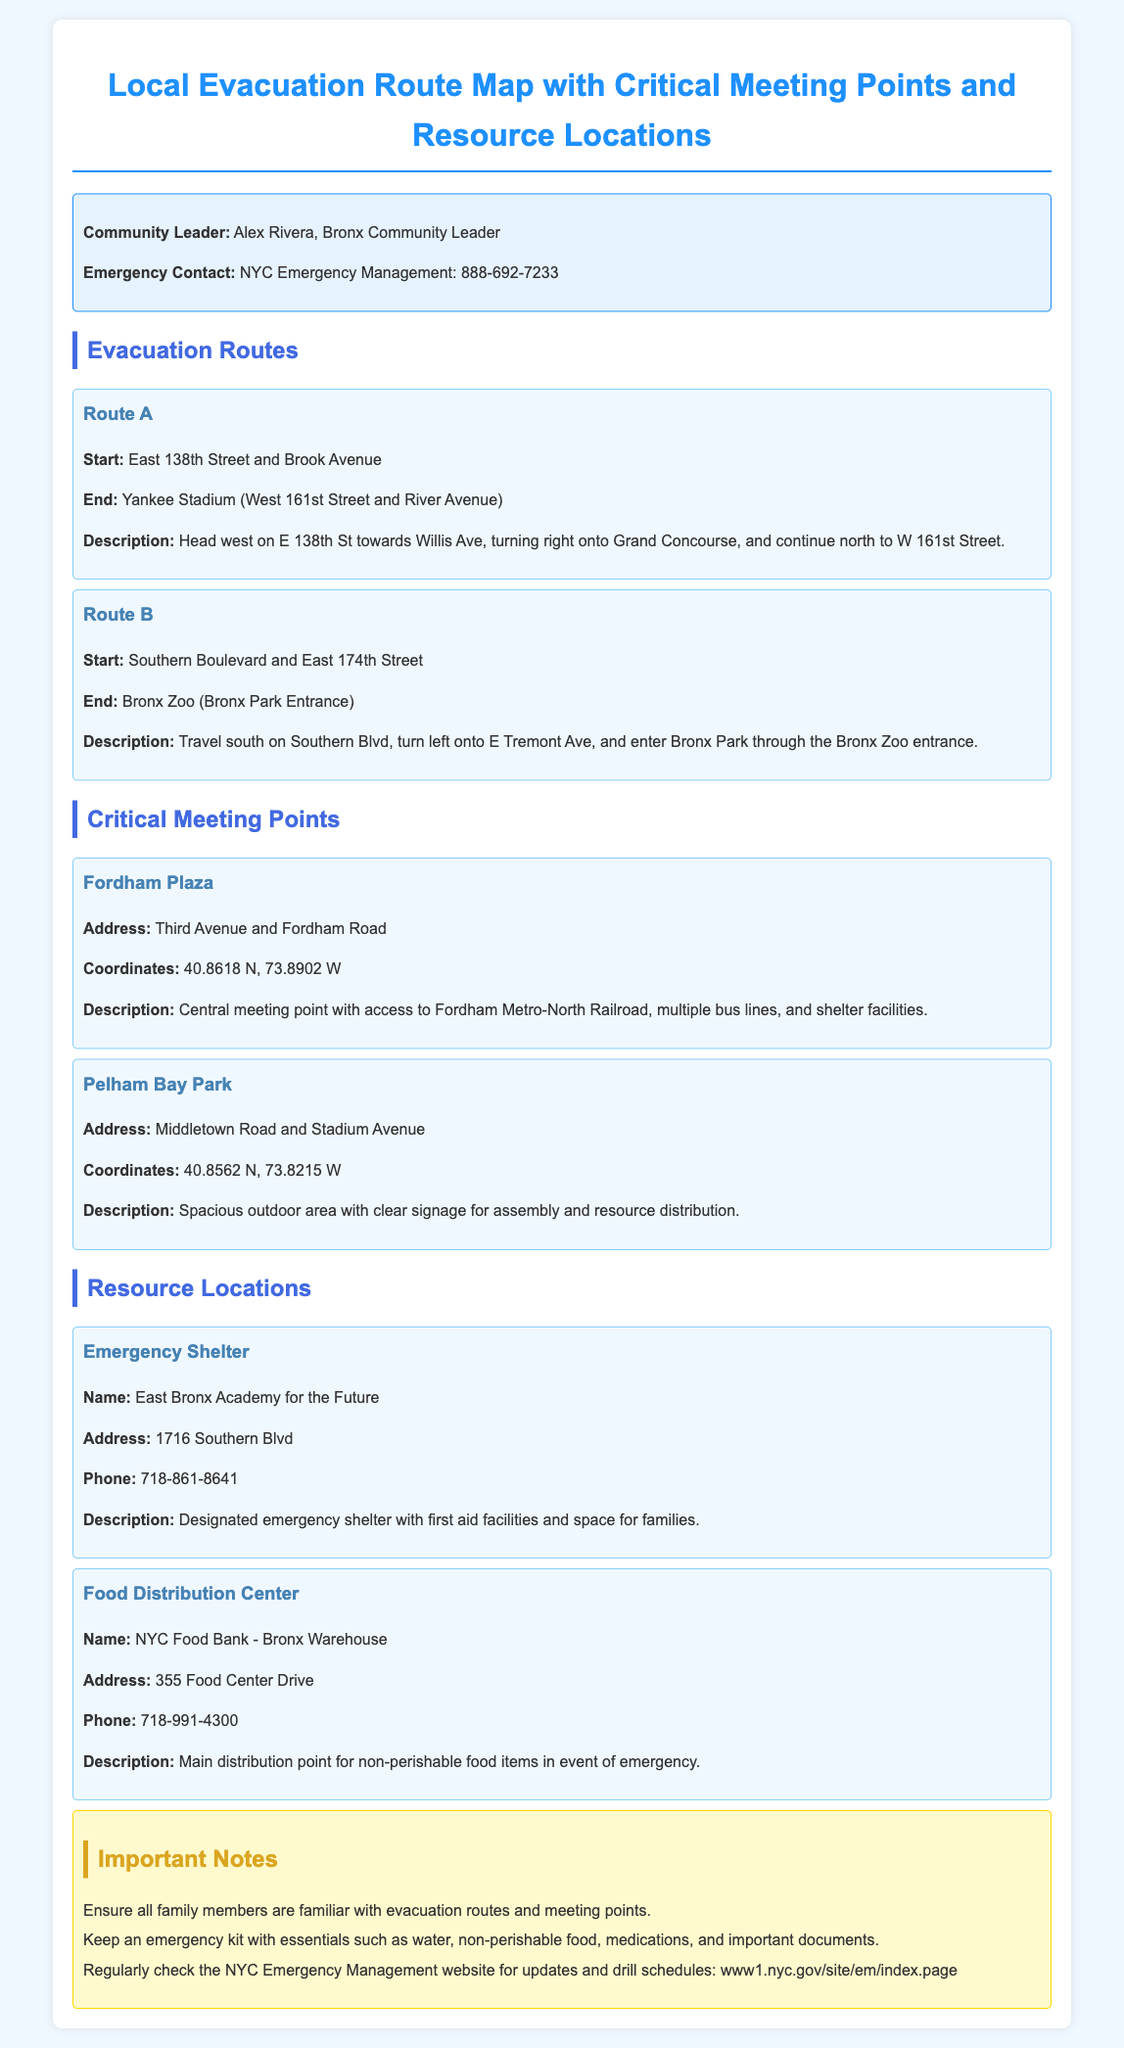What is the name of the community leader? The document states that the community leader is Alex Rivera.
Answer: Alex Rivera What is the emergency contact number for NYC Emergency Management? The document provides the emergency contact number as 888-692-7233.
Answer: 888-692-7233 What is the starting point of Route A? The document states the starting point of Route A is East 138th Street and Brook Avenue.
Answer: East 138th Street and Brook Avenue Which location serves as a Food Distribution Center? The document mentions NYC Food Bank - Bronx Warehouse as the Food Distribution Center.
Answer: NYC Food Bank - Bronx Warehouse What are the coordinates of Fordham Plaza? The document lists the coordinates of Fordham Plaza as 40.8618 N, 73.8902 W.
Answer: 40.8618 N, 73.8902 W What is the phone number for East Bronx Academy for the Future? The document reveals that the phone number for East Bronx Academy for the Future is 718-861-8641.
Answer: 718-861-8641 Which route ends at Bronx Zoo? The document states that Route B ends at Bronx Zoo.
Answer: Route B What is a recommended item to keep in an emergency kit? The document suggests keeping essentials like water in an emergency kit.
Answer: water How many meeting points are mentioned in the document? The document mentions two meeting points: Fordham Plaza and Pelham Bay Park.
Answer: two 